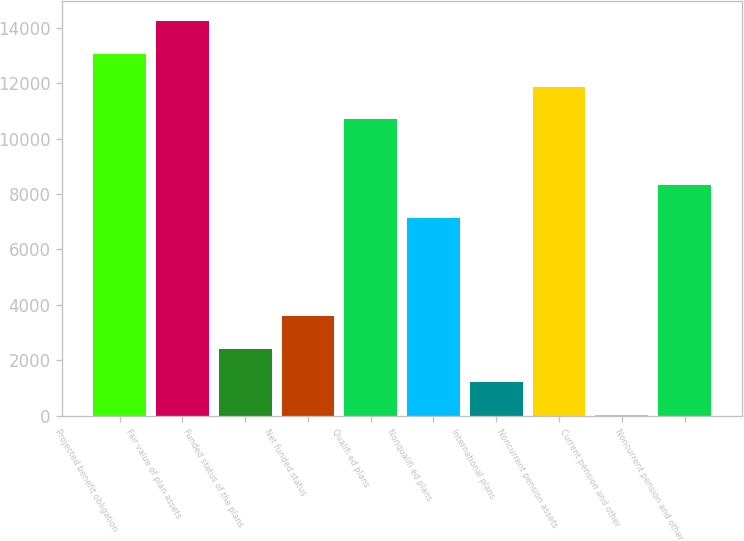<chart> <loc_0><loc_0><loc_500><loc_500><bar_chart><fcel>Projected benefit obligation<fcel>Fair value of plan assets<fcel>Funded status of the plans<fcel>Net funded status<fcel>Qualifi ed plans<fcel>Nonqualifi ed plans<fcel>International plans<fcel>Noncurrent pension assets<fcel>Current pension and other<fcel>Noncurrent pension and other<nl><fcel>13063.7<fcel>14248.4<fcel>2401.4<fcel>3586.1<fcel>10694.3<fcel>7140.2<fcel>1216.7<fcel>11879<fcel>32<fcel>8324.9<nl></chart> 